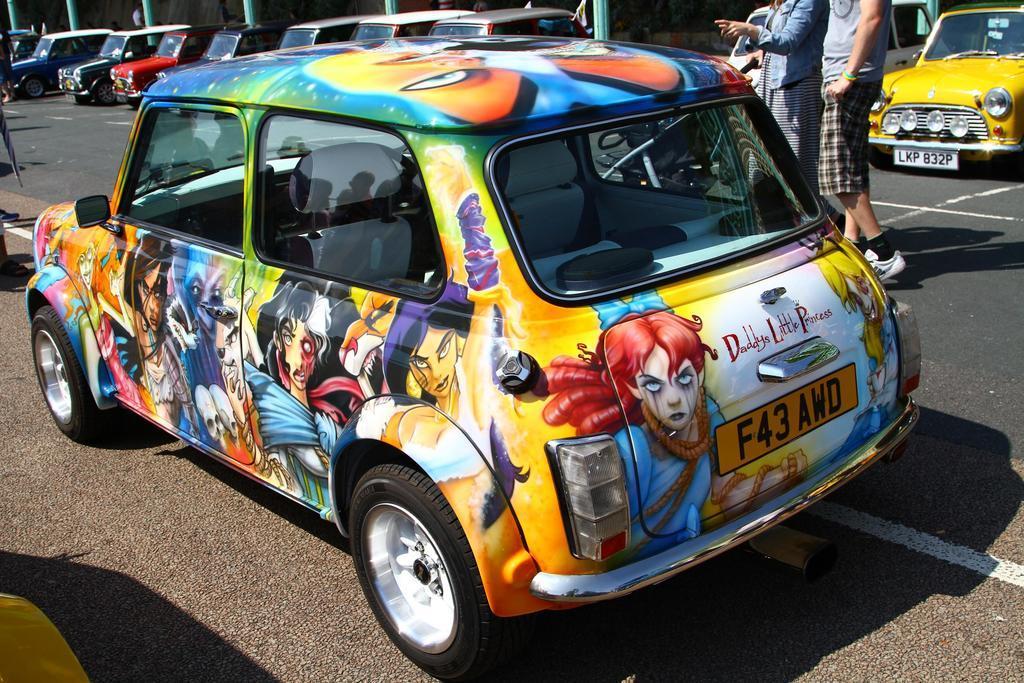Please provide a concise description of this image. In this image we can see a graffiti car on the road. In the background we can see two persons walking. We can also see some cars parked on the road. Poles are also visible. 